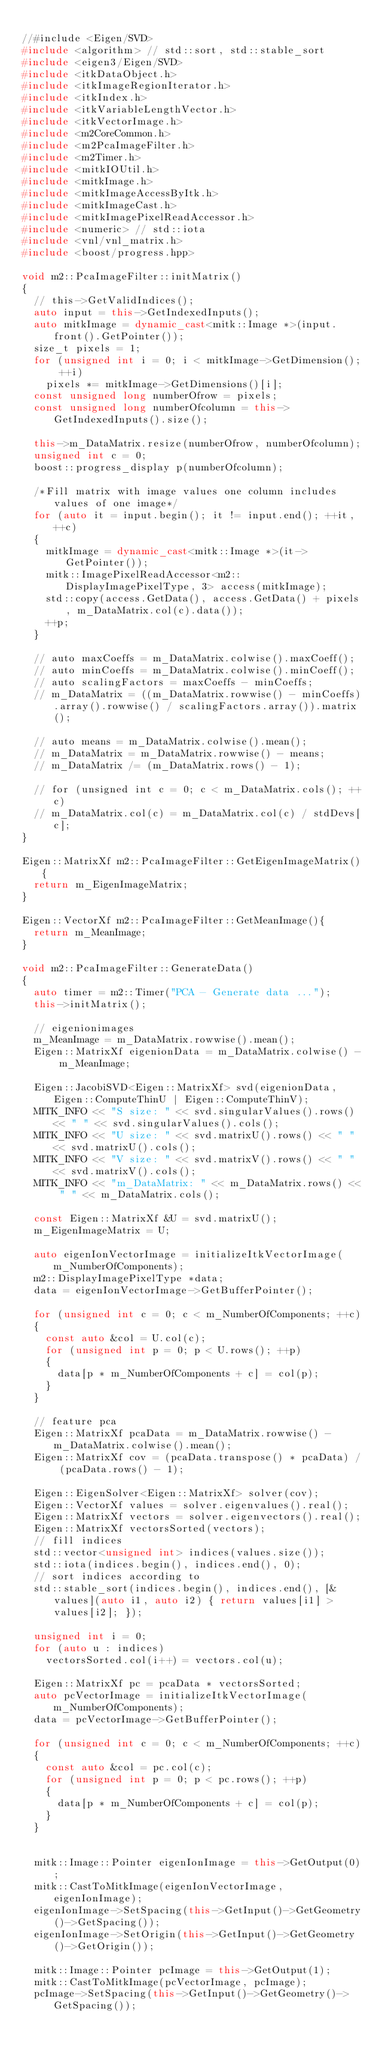Convert code to text. <code><loc_0><loc_0><loc_500><loc_500><_C++_>
//#include <Eigen/SVD>
#include <algorithm> // std::sort, std::stable_sort
#include <eigen3/Eigen/SVD>
#include <itkDataObject.h>
#include <itkImageRegionIterator.h>
#include <itkIndex.h>
#include <itkVariableLengthVector.h>
#include <itkVectorImage.h>
#include <m2CoreCommon.h>
#include <m2PcaImageFilter.h>
#include <m2Timer.h>
#include <mitkIOUtil.h>
#include <mitkImage.h>
#include <mitkImageAccessByItk.h>
#include <mitkImageCast.h>
#include <mitkImagePixelReadAccessor.h>
#include <numeric> // std::iota
#include <vnl/vnl_matrix.h>
#include <boost/progress.hpp>

void m2::PcaImageFilter::initMatrix()
{
  // this->GetValidIndices();
  auto input = this->GetIndexedInputs();
  auto mitkImage = dynamic_cast<mitk::Image *>(input.front().GetPointer());
  size_t pixels = 1;
  for (unsigned int i = 0; i < mitkImage->GetDimension(); ++i)
    pixels *= mitkImage->GetDimensions()[i];
  const unsigned long numberOfrow = pixels;
  const unsigned long numberOfcolumn = this->GetIndexedInputs().size();

  this->m_DataMatrix.resize(numberOfrow, numberOfcolumn);
  unsigned int c = 0;
  boost::progress_display p(numberOfcolumn);
  
  /*Fill matrix with image values one column includes values of one image*/
  for (auto it = input.begin(); it != input.end(); ++it, ++c)
  {
    mitkImage = dynamic_cast<mitk::Image *>(it->GetPointer());
    mitk::ImagePixelReadAccessor<m2::DisplayImagePixelType, 3> access(mitkImage);
    std::copy(access.GetData(), access.GetData() + pixels, m_DataMatrix.col(c).data());
    ++p;
  }

  // auto maxCoeffs = m_DataMatrix.colwise().maxCoeff();
  // auto minCoeffs = m_DataMatrix.colwise().minCoeff();
  // auto scalingFactors = maxCoeffs - minCoeffs;
  // m_DataMatrix = ((m_DataMatrix.rowwise() - minCoeffs).array().rowwise() / scalingFactors.array()).matrix();

  // auto means = m_DataMatrix.colwise().mean();
  // m_DataMatrix = m_DataMatrix.rowwise() - means;
  // m_DataMatrix /= (m_DataMatrix.rows() - 1);

  // for (unsigned int c = 0; c < m_DataMatrix.cols(); ++c)
  // m_DataMatrix.col(c) = m_DataMatrix.col(c) / stdDevs[c];
}

Eigen::MatrixXf m2::PcaImageFilter::GetEigenImageMatrix(){
  return m_EigenImageMatrix;
}

Eigen::VectorXf m2::PcaImageFilter::GetMeanImage(){
  return m_MeanImage;
}

void m2::PcaImageFilter::GenerateData()
{
  auto timer = m2::Timer("PCA - Generate data ...");
  this->initMatrix();

  // eigenionimages
  m_MeanImage = m_DataMatrix.rowwise().mean();
  Eigen::MatrixXf eigenionData = m_DataMatrix.colwise() - m_MeanImage;

  Eigen::JacobiSVD<Eigen::MatrixXf> svd(eigenionData, Eigen::ComputeThinU | Eigen::ComputeThinV);
  MITK_INFO << "S size: " << svd.singularValues().rows() << " " << svd.singularValues().cols();
  MITK_INFO << "U size: " << svd.matrixU().rows() << " " << svd.matrixU().cols();
  MITK_INFO << "V size: " << svd.matrixV().rows() << " " << svd.matrixV().cols();
  MITK_INFO << "m_DataMatrix: " << m_DataMatrix.rows() << " " << m_DataMatrix.cols();

  const Eigen::MatrixXf &U = svd.matrixU();
  m_EigenImageMatrix = U;

  auto eigenIonVectorImage = initializeItkVectorImage(m_NumberOfComponents);
  m2::DisplayImagePixelType *data;
  data = eigenIonVectorImage->GetBufferPointer();

  for (unsigned int c = 0; c < m_NumberOfComponents; ++c)
  {
    const auto &col = U.col(c);
    for (unsigned int p = 0; p < U.rows(); ++p)
    {
      data[p * m_NumberOfComponents + c] = col(p);
    }
  }

  // feature pca
  Eigen::MatrixXf pcaData = m_DataMatrix.rowwise() - m_DataMatrix.colwise().mean();
  Eigen::MatrixXf cov = (pcaData.transpose() * pcaData) / (pcaData.rows() - 1);

  Eigen::EigenSolver<Eigen::MatrixXf> solver(cov);
  Eigen::VectorXf values = solver.eigenvalues().real();
  Eigen::MatrixXf vectors = solver.eigenvectors().real();
  Eigen::MatrixXf vectorsSorted(vectors);
  // fill indices
  std::vector<unsigned int> indices(values.size());
  std::iota(indices.begin(), indices.end(), 0);
  // sort indices according to
  std::stable_sort(indices.begin(), indices.end(), [&values](auto i1, auto i2) { return values[i1] > values[i2]; });

  unsigned int i = 0;
  for (auto u : indices)
    vectorsSorted.col(i++) = vectors.col(u);

  Eigen::MatrixXf pc = pcaData * vectorsSorted;
  auto pcVectorImage = initializeItkVectorImage(m_NumberOfComponents);
  data = pcVectorImage->GetBufferPointer();

  for (unsigned int c = 0; c < m_NumberOfComponents; ++c)
  {
    const auto &col = pc.col(c);
    for (unsigned int p = 0; p < pc.rows(); ++p)
    {
      data[p * m_NumberOfComponents + c] = col(p);
    }
  }
  

  mitk::Image::Pointer eigenIonImage = this->GetOutput(0);
  mitk::CastToMitkImage(eigenIonVectorImage, eigenIonImage);
  eigenIonImage->SetSpacing(this->GetInput()->GetGeometry()->GetSpacing());
  eigenIonImage->SetOrigin(this->GetInput()->GetGeometry()->GetOrigin());

  mitk::Image::Pointer pcImage = this->GetOutput(1);
  mitk::CastToMitkImage(pcVectorImage, pcImage);
  pcImage->SetSpacing(this->GetInput()->GetGeometry()->GetSpacing());</code> 